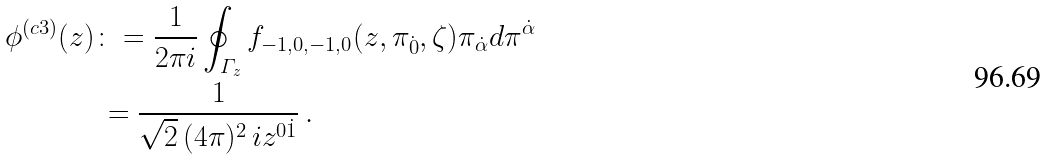Convert formula to latex. <formula><loc_0><loc_0><loc_500><loc_500>\phi ^ { ( c 3 ) } ( z ) & \colon = \frac { 1 } { 2 \pi i } \oint _ { \varGamma _ { z } } f _ { - 1 , 0 , - 1 , 0 } ( z , \pi _ { \dot { 0 } } , \zeta ) \pi _ { \dot { \alpha } } d \pi ^ { \dot { \alpha } } \\ & \, = \frac { 1 } { \sqrt { 2 } \, ( 4 \pi ) ^ { 2 } \, i z ^ { 0 \dot { 1 } } } \, .</formula> 